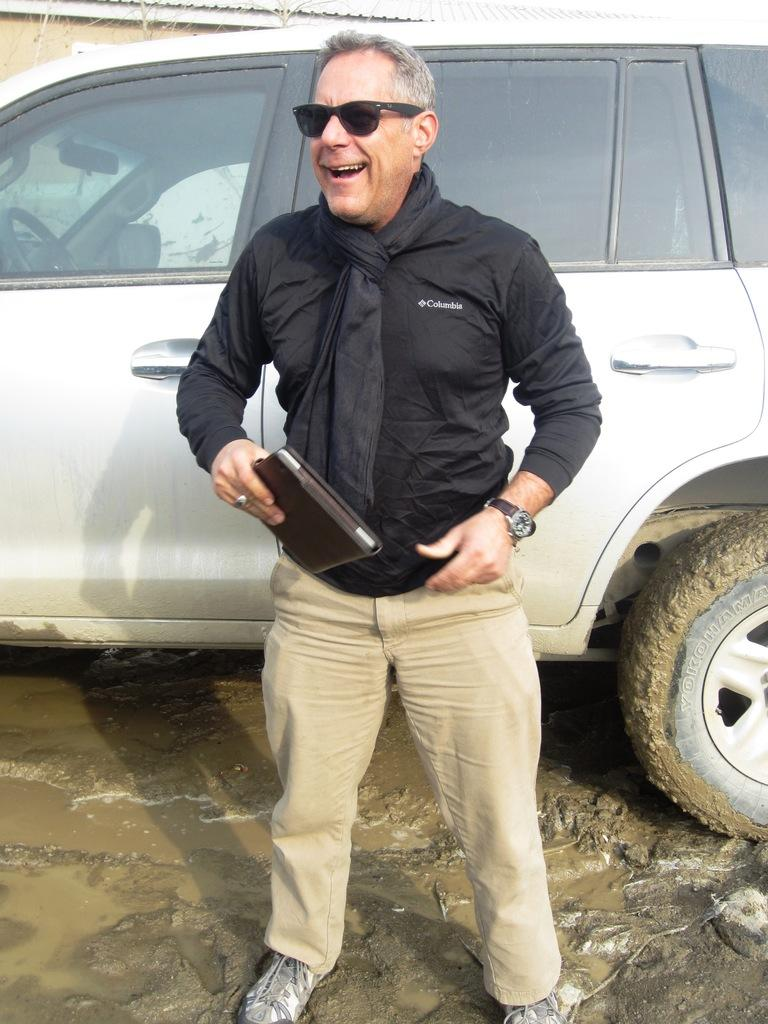What is the main subject of the image? There is a man standing in the image. What is the man holding in the image? The man is holding an object. What else can be seen in the image besides the man? There is a vehicle in the image. What is visible in the background of the image? There appears to be a shed in the background of the image. How many deer can be seen in the image? There are no deer present in the image. Is there a plane visible in the image? There is no plane visible in the image. 